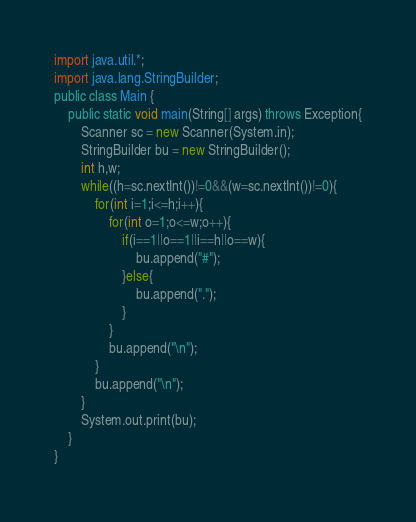<code> <loc_0><loc_0><loc_500><loc_500><_Java_>import java.util.*;
import java.lang.StringBuilder;
public class Main {
	public static void main(String[] args) throws Exception{
		Scanner sc = new Scanner(System.in);
		StringBuilder bu = new StringBuilder();
		int h,w;
		while((h=sc.nextInt())!=0&&(w=sc.nextInt())!=0){
			for(int i=1;i<=h;i++){
				for(int o=1;o<=w;o++){
					if(i==1||o==1||i==h||o==w){
						bu.append("#");
					}else{
						bu.append(".");
					}
				}
				bu.append("\n");
			}
			bu.append("\n");
		}
		System.out.print(bu);
	}
}</code> 